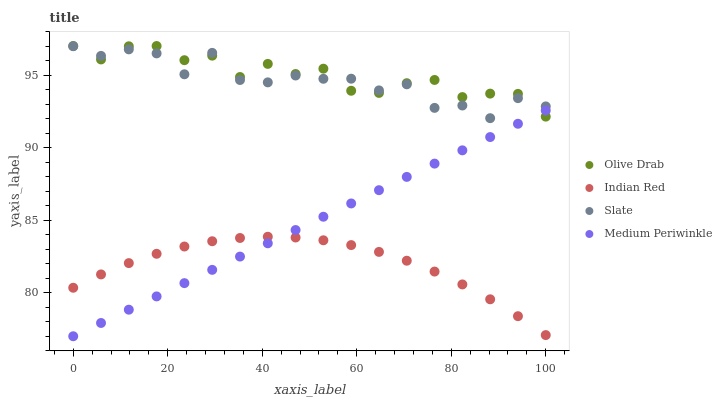Does Indian Red have the minimum area under the curve?
Answer yes or no. Yes. Does Olive Drab have the maximum area under the curve?
Answer yes or no. Yes. Does Medium Periwinkle have the minimum area under the curve?
Answer yes or no. No. Does Medium Periwinkle have the maximum area under the curve?
Answer yes or no. No. Is Medium Periwinkle the smoothest?
Answer yes or no. Yes. Is Slate the roughest?
Answer yes or no. Yes. Is Indian Red the smoothest?
Answer yes or no. No. Is Indian Red the roughest?
Answer yes or no. No. Does Medium Periwinkle have the lowest value?
Answer yes or no. Yes. Does Indian Red have the lowest value?
Answer yes or no. No. Does Olive Drab have the highest value?
Answer yes or no. Yes. Does Medium Periwinkle have the highest value?
Answer yes or no. No. Is Indian Red less than Olive Drab?
Answer yes or no. Yes. Is Slate greater than Medium Periwinkle?
Answer yes or no. Yes. Does Olive Drab intersect Medium Periwinkle?
Answer yes or no. Yes. Is Olive Drab less than Medium Periwinkle?
Answer yes or no. No. Is Olive Drab greater than Medium Periwinkle?
Answer yes or no. No. Does Indian Red intersect Olive Drab?
Answer yes or no. No. 